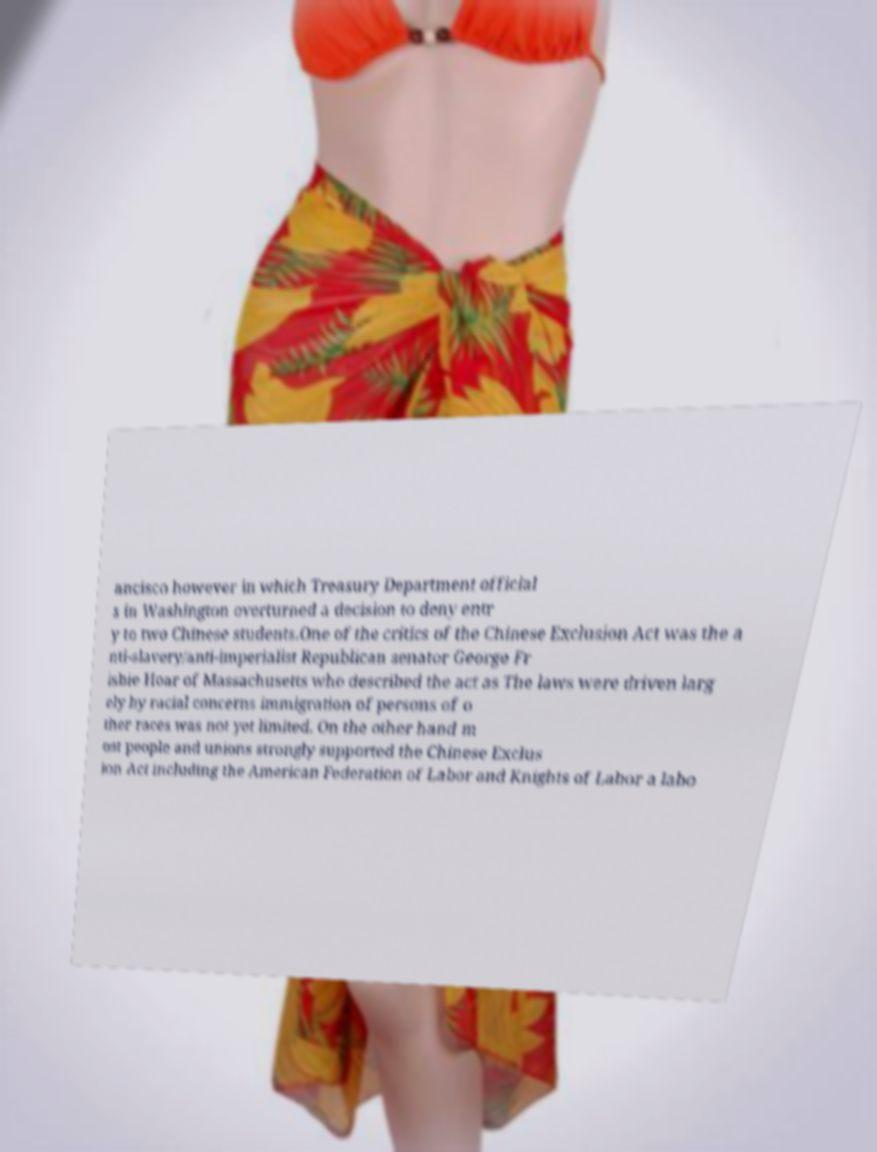There's text embedded in this image that I need extracted. Can you transcribe it verbatim? ancisco however in which Treasury Department official s in Washington overturned a decision to deny entr y to two Chinese students.One of the critics of the Chinese Exclusion Act was the a nti-slavery/anti-imperialist Republican senator George Fr isbie Hoar of Massachusetts who described the act as The laws were driven larg ely by racial concerns immigration of persons of o ther races was not yet limited. On the other hand m ost people and unions strongly supported the Chinese Exclus ion Act including the American Federation of Labor and Knights of Labor a labo 